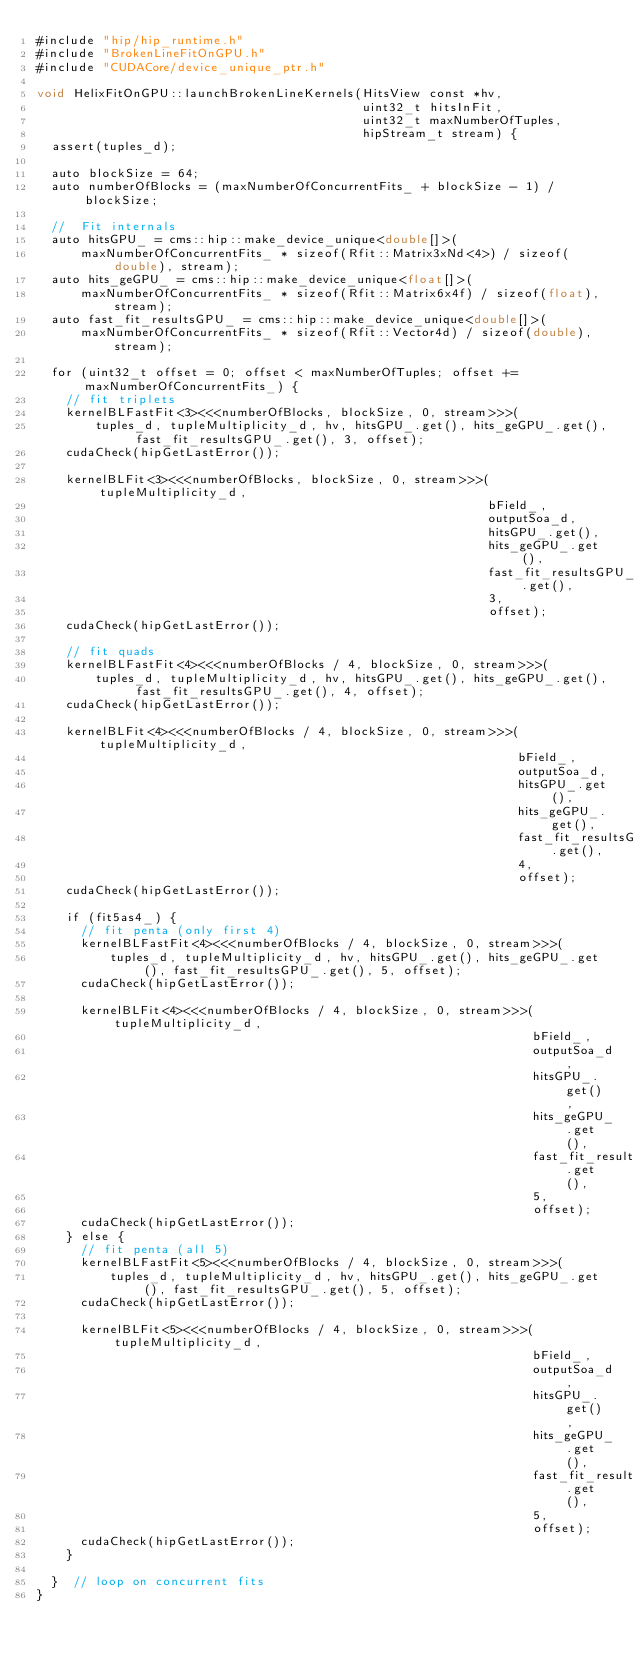<code> <loc_0><loc_0><loc_500><loc_500><_Cuda_>#include "hip/hip_runtime.h"
#include "BrokenLineFitOnGPU.h"
#include "CUDACore/device_unique_ptr.h"

void HelixFitOnGPU::launchBrokenLineKernels(HitsView const *hv,
                                            uint32_t hitsInFit,
                                            uint32_t maxNumberOfTuples,
                                            hipStream_t stream) {
  assert(tuples_d);

  auto blockSize = 64;
  auto numberOfBlocks = (maxNumberOfConcurrentFits_ + blockSize - 1) / blockSize;

  //  Fit internals
  auto hitsGPU_ = cms::hip::make_device_unique<double[]>(
      maxNumberOfConcurrentFits_ * sizeof(Rfit::Matrix3xNd<4>) / sizeof(double), stream);
  auto hits_geGPU_ = cms::hip::make_device_unique<float[]>(
      maxNumberOfConcurrentFits_ * sizeof(Rfit::Matrix6x4f) / sizeof(float), stream);
  auto fast_fit_resultsGPU_ = cms::hip::make_device_unique<double[]>(
      maxNumberOfConcurrentFits_ * sizeof(Rfit::Vector4d) / sizeof(double), stream);

  for (uint32_t offset = 0; offset < maxNumberOfTuples; offset += maxNumberOfConcurrentFits_) {
    // fit triplets
    kernelBLFastFit<3><<<numberOfBlocks, blockSize, 0, stream>>>(
        tuples_d, tupleMultiplicity_d, hv, hitsGPU_.get(), hits_geGPU_.get(), fast_fit_resultsGPU_.get(), 3, offset);
    cudaCheck(hipGetLastError());

    kernelBLFit<3><<<numberOfBlocks, blockSize, 0, stream>>>(tupleMultiplicity_d,
                                                             bField_,
                                                             outputSoa_d,
                                                             hitsGPU_.get(),
                                                             hits_geGPU_.get(),
                                                             fast_fit_resultsGPU_.get(),
                                                             3,
                                                             offset);
    cudaCheck(hipGetLastError());

    // fit quads
    kernelBLFastFit<4><<<numberOfBlocks / 4, blockSize, 0, stream>>>(
        tuples_d, tupleMultiplicity_d, hv, hitsGPU_.get(), hits_geGPU_.get(), fast_fit_resultsGPU_.get(), 4, offset);
    cudaCheck(hipGetLastError());

    kernelBLFit<4><<<numberOfBlocks / 4, blockSize, 0, stream>>>(tupleMultiplicity_d,
                                                                 bField_,
                                                                 outputSoa_d,
                                                                 hitsGPU_.get(),
                                                                 hits_geGPU_.get(),
                                                                 fast_fit_resultsGPU_.get(),
                                                                 4,
                                                                 offset);
    cudaCheck(hipGetLastError());

    if (fit5as4_) {
      // fit penta (only first 4)
      kernelBLFastFit<4><<<numberOfBlocks / 4, blockSize, 0, stream>>>(
          tuples_d, tupleMultiplicity_d, hv, hitsGPU_.get(), hits_geGPU_.get(), fast_fit_resultsGPU_.get(), 5, offset);
      cudaCheck(hipGetLastError());

      kernelBLFit<4><<<numberOfBlocks / 4, blockSize, 0, stream>>>(tupleMultiplicity_d,
                                                                   bField_,
                                                                   outputSoa_d,
                                                                   hitsGPU_.get(),
                                                                   hits_geGPU_.get(),
                                                                   fast_fit_resultsGPU_.get(),
                                                                   5,
                                                                   offset);
      cudaCheck(hipGetLastError());
    } else {
      // fit penta (all 5)
      kernelBLFastFit<5><<<numberOfBlocks / 4, blockSize, 0, stream>>>(
          tuples_d, tupleMultiplicity_d, hv, hitsGPU_.get(), hits_geGPU_.get(), fast_fit_resultsGPU_.get(), 5, offset);
      cudaCheck(hipGetLastError());

      kernelBLFit<5><<<numberOfBlocks / 4, blockSize, 0, stream>>>(tupleMultiplicity_d,
                                                                   bField_,
                                                                   outputSoa_d,
                                                                   hitsGPU_.get(),
                                                                   hits_geGPU_.get(),
                                                                   fast_fit_resultsGPU_.get(),
                                                                   5,
                                                                   offset);
      cudaCheck(hipGetLastError());
    }

  }  // loop on concurrent fits
}
</code> 